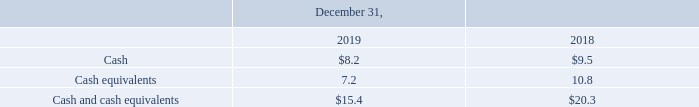Cash and Cash Equivalents
Highly liquid instruments purchased with original maturities of three months or less are considered cash equivalents. Cash equivalents are invested with high credit quality financial institutions and consist of short-term investments, such as demand deposit accounts, money market accounts, money market funds and time deposits. The carrying amounts of these instruments reported in the Consolidated Balance Sheets approximate their fair value because of their immediate or short-term maturities.
Cash and cash equivalents are unrestricted and include the following (in millions):
What was considered by the company to be cash equivalents? Highly liquid instruments purchased with original maturities of three months or less. Which years does the table provide information for the company's Cash and cash equivalents are unrestricted? 2019, 2018. What was the total cash and cash equivalents in 2018?
Answer scale should be: million. 20.3. What was the change in cash equivalents between 2018 and 2019?
Answer scale should be: million. 7.2-10.8
Answer: -3.6. What was the change in Cash between 2018 and 2019?
Answer scale should be: million. 8.2-9.5
Answer: -1.3. What was the percentage change in Cash and cash equivalents between 2018 and 2019?
Answer scale should be: percent. (15.4-20.3)/20.3
Answer: -24.14. 